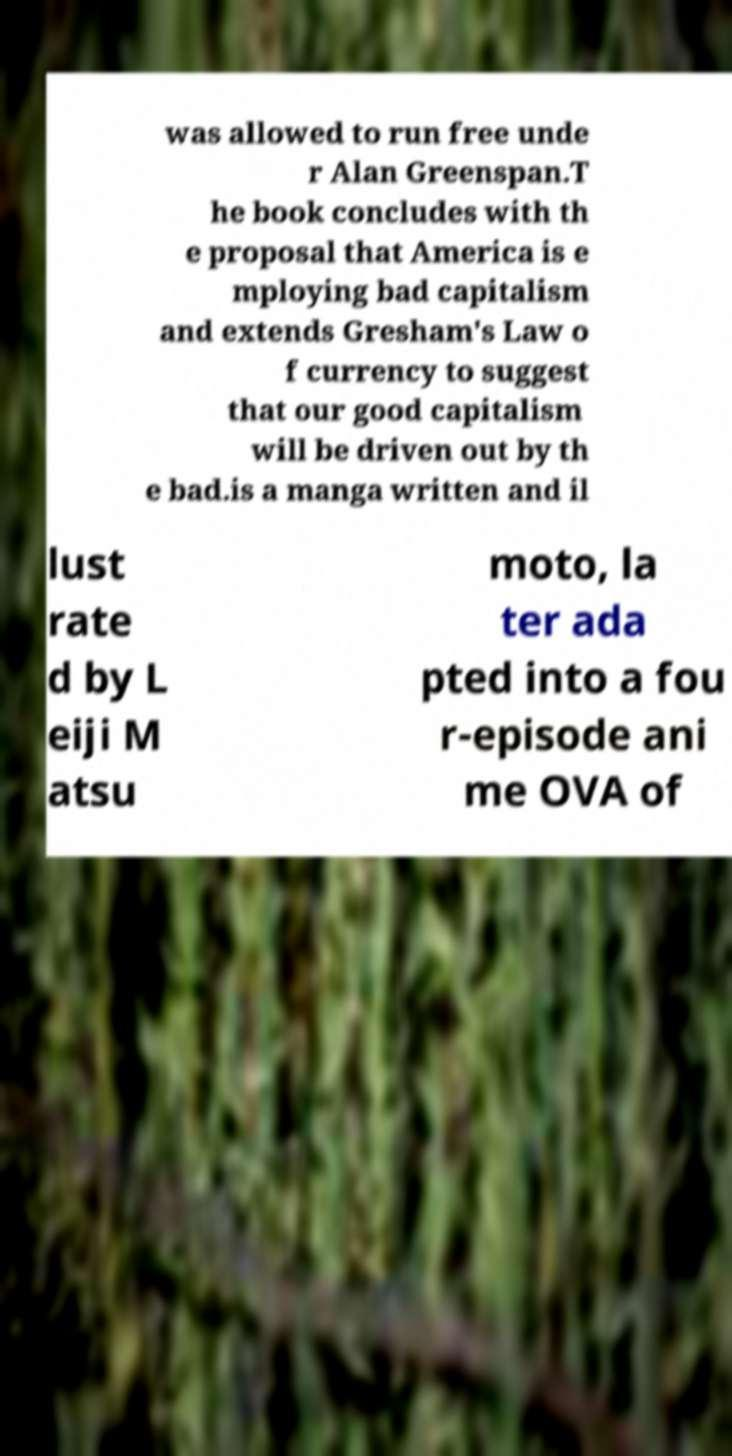There's text embedded in this image that I need extracted. Can you transcribe it verbatim? was allowed to run free unde r Alan Greenspan.T he book concludes with th e proposal that America is e mploying bad capitalism and extends Gresham's Law o f currency to suggest that our good capitalism will be driven out by th e bad.is a manga written and il lust rate d by L eiji M atsu moto, la ter ada pted into a fou r-episode ani me OVA of 